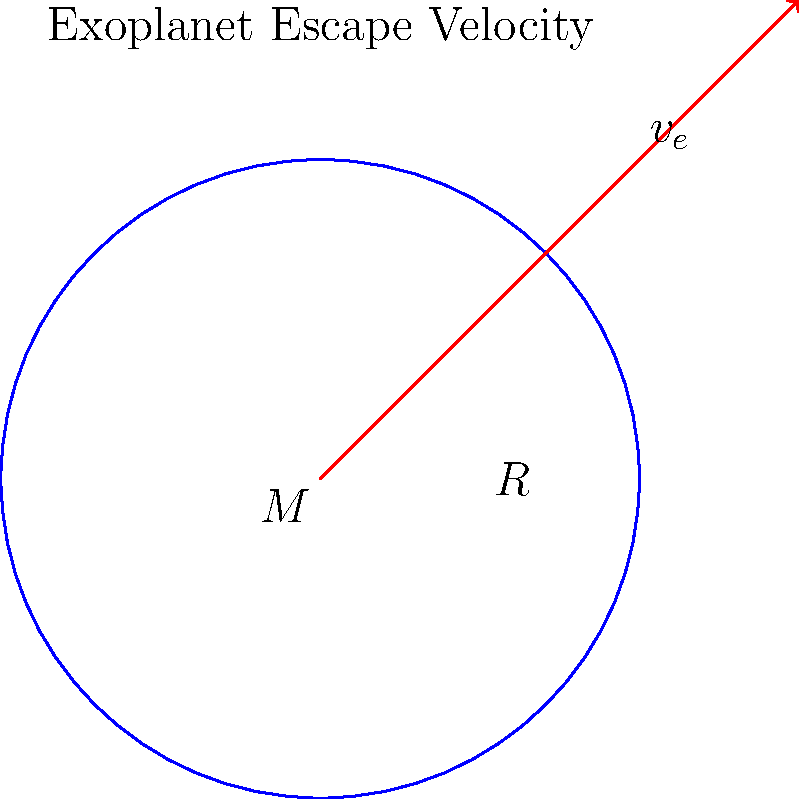An exoplanet has been discovered with a mass $M = 2.5 \times 10^{24}$ kg and a radius $R = 5000$ km. Calculate the escape velocity $v_e$ from the surface of this exoplanet. Given: The gravitational constant $G = 6.67 \times 10^{-11}$ m³/kg·s². Express your answer in km/s, rounded to two decimal places. To calculate the escape velocity from the surface of an exoplanet, we use the formula:

$$ v_e = \sqrt{\frac{2GM}{R}} $$

Where:
$v_e$ is the escape velocity
$G$ is the gravitational constant
$M$ is the mass of the exoplanet
$R$ is the radius of the exoplanet

Let's solve this step by step:

1) First, let's convert the radius to meters:
   $R = 5000 \text{ km} = 5 \times 10^6 \text{ m}$

2) Now, let's substitute the values into the equation:
   $$ v_e = \sqrt{\frac{2 \cdot (6.67 \times 10^{-11}) \cdot (2.5 \times 10^{24})}{5 \times 10^6}} $$

3) Simplify inside the square root:
   $$ v_e = \sqrt{\frac{3.335 \times 10^{14}}{5 \times 10^6}} = \sqrt{6.67 \times 10^7} $$

4) Calculate the square root:
   $$ v_e = 8,167.01 \text{ m/s} $$

5) Convert to km/s:
   $$ v_e = 8.17 \text{ km/s} $$

Thus, the escape velocity from the surface of this exoplanet is approximately 8.17 km/s.
Answer: 8.17 km/s 